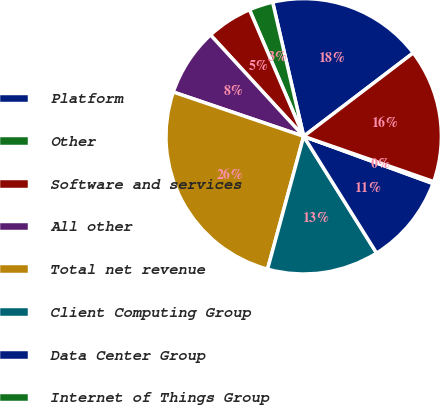Convert chart. <chart><loc_0><loc_0><loc_500><loc_500><pie_chart><fcel>Platform<fcel>Other<fcel>Software and services<fcel>All other<fcel>Total net revenue<fcel>Client Computing Group<fcel>Data Center Group<fcel>Internet of Things Group<fcel>Total operating income<nl><fcel>18.26%<fcel>2.82%<fcel>5.39%<fcel>7.96%<fcel>25.98%<fcel>13.11%<fcel>10.54%<fcel>0.24%<fcel>15.69%<nl></chart> 